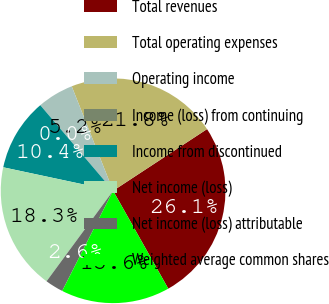Convert chart to OTSL. <chart><loc_0><loc_0><loc_500><loc_500><pie_chart><fcel>Total revenues<fcel>Total operating expenses<fcel>Operating income<fcel>Income (loss) from continuing<fcel>Income from discontinued<fcel>Net income (loss)<fcel>Net income (loss) attributable<fcel>Weighted average common shares<nl><fcel>26.08%<fcel>21.76%<fcel>5.22%<fcel>0.0%<fcel>10.43%<fcel>18.26%<fcel>2.61%<fcel>15.65%<nl></chart> 